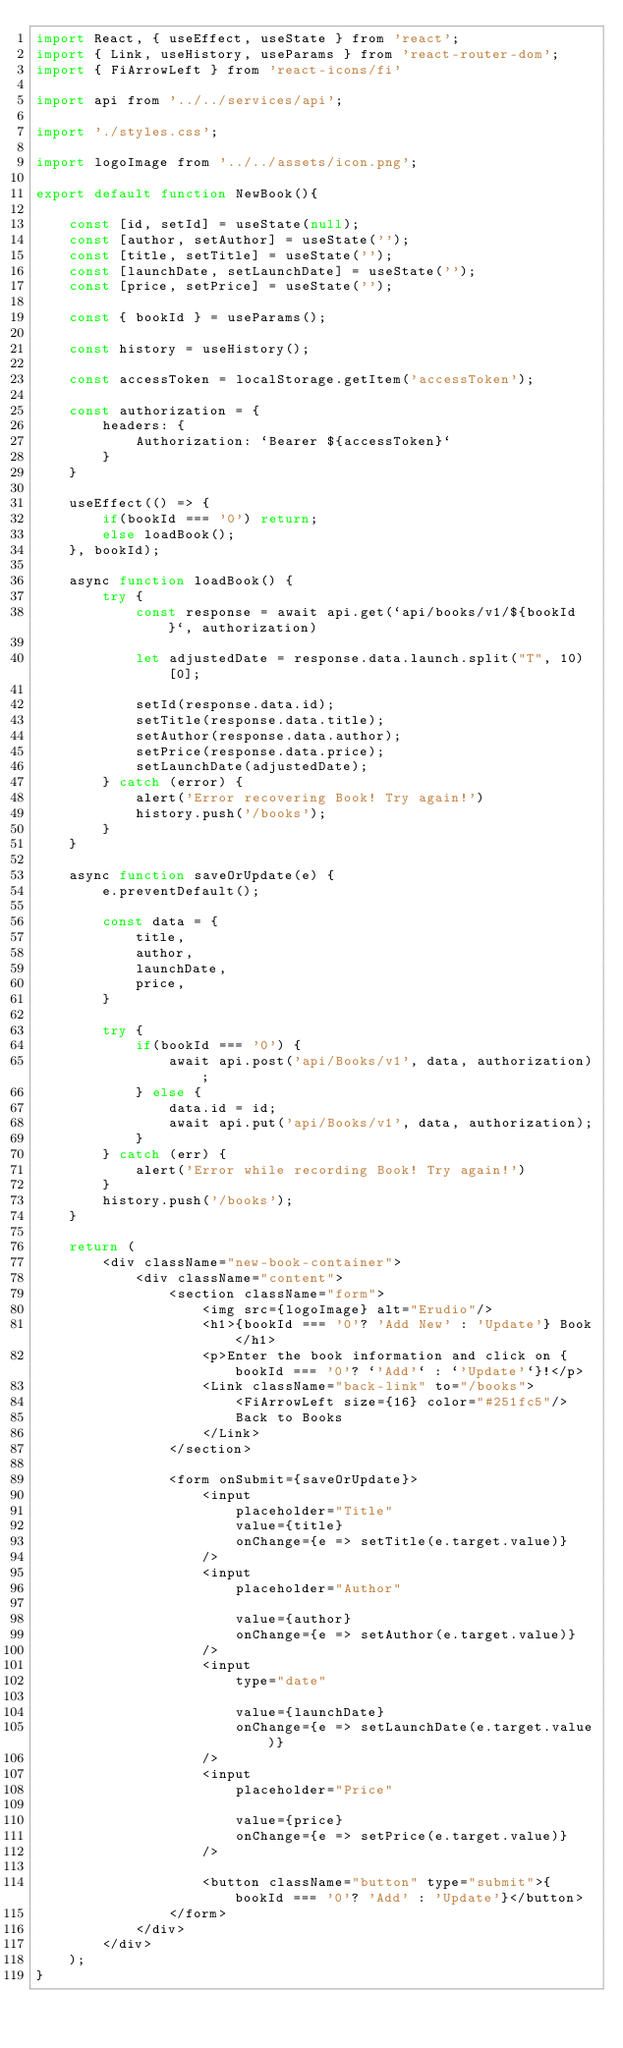<code> <loc_0><loc_0><loc_500><loc_500><_JavaScript_>import React, { useEffect, useState } from 'react';
import { Link, useHistory, useParams } from 'react-router-dom';
import { FiArrowLeft } from 'react-icons/fi'

import api from '../../services/api';

import './styles.css';

import logoImage from '../../assets/icon.png';

export default function NewBook(){

    const [id, setId] = useState(null);
    const [author, setAuthor] = useState('');
    const [title, setTitle] = useState('');
    const [launchDate, setLaunchDate] = useState('');
    const [price, setPrice] = useState('');

    const { bookId } = useParams();

    const history = useHistory();

    const accessToken = localStorage.getItem('accessToken');

    const authorization = {
        headers: {
            Authorization: `Bearer ${accessToken}`
        }
    }

    useEffect(() => {
        if(bookId === '0') return;
        else loadBook();
    }, bookId);

    async function loadBook() {
        try {
            const response = await api.get(`api/books/v1/${bookId}`, authorization)

            let adjustedDate = response.data.launch.split("T", 10)[0];

            setId(response.data.id);
            setTitle(response.data.title);
            setAuthor(response.data.author);
            setPrice(response.data.price);
            setLaunchDate(adjustedDate);
        } catch (error) {            
            alert('Error recovering Book! Try again!')
            history.push('/books');
        }
    }

    async function saveOrUpdate(e) {
        e.preventDefault();

        const data = {
            title,
            author,
            launchDate,
            price,
        }

        try {
            if(bookId === '0') {
                await api.post('api/Books/v1', data, authorization);
            } else {
                data.id = id;
                await api.put('api/Books/v1', data, authorization);
            }
        } catch (err) {
            alert('Error while recording Book! Try again!')
        }
        history.push('/books');
    }

    return (
        <div className="new-book-container">
            <div className="content">
                <section className="form">
                    <img src={logoImage} alt="Erudio"/>
                    <h1>{bookId === '0'? 'Add New' : 'Update'} Book</h1>
                    <p>Enter the book information and click on {bookId === '0'? `'Add'` : `'Update'`}!</p>
                    <Link className="back-link" to="/books">
                        <FiArrowLeft size={16} color="#251fc5"/>
                        Back to Books
                    </Link>
                </section>

                <form onSubmit={saveOrUpdate}>
                    <input 
                        placeholder="Title"
                        value={title}
                        onChange={e => setTitle(e.target.value)}
                    />
                    <input 
                        placeholder="Author"
                        
                        value={author}
                        onChange={e => setAuthor(e.target.value)}
                    />
                    <input 
                        type="date"
                        
                        value={launchDate}
                        onChange={e => setLaunchDate(e.target.value)}
                    />
                    <input 
                        placeholder="Price"
                        
                        value={price}
                        onChange={e => setPrice(e.target.value)}
                    />

                    <button className="button" type="submit">{bookId === '0'? 'Add' : 'Update'}</button>
                </form>
            </div>
        </div>
    );
}</code> 